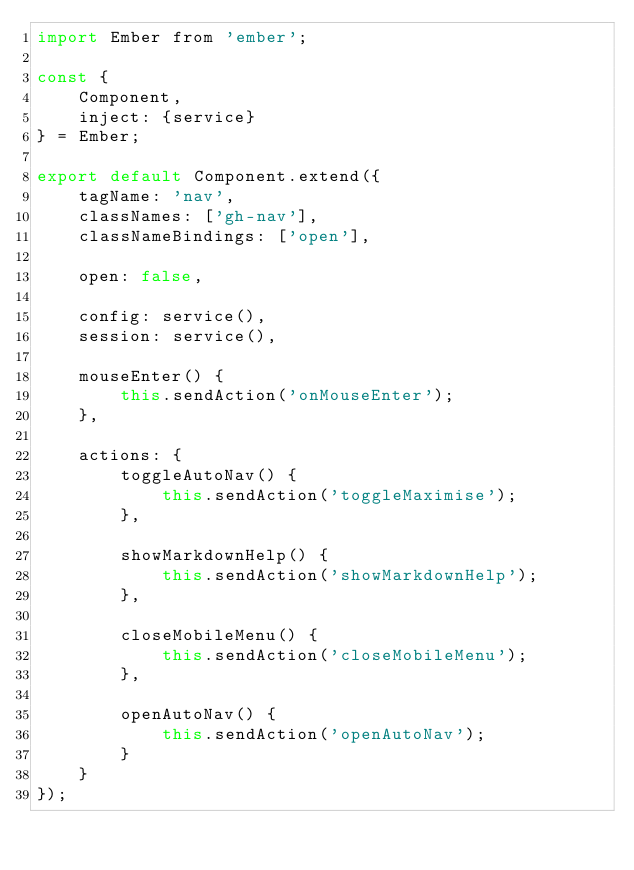<code> <loc_0><loc_0><loc_500><loc_500><_JavaScript_>import Ember from 'ember';

const {
    Component,
    inject: {service}
} = Ember;

export default Component.extend({
    tagName: 'nav',
    classNames: ['gh-nav'],
    classNameBindings: ['open'],

    open: false,

    config: service(),
    session: service(),

    mouseEnter() {
        this.sendAction('onMouseEnter');
    },

    actions: {
        toggleAutoNav() {
            this.sendAction('toggleMaximise');
        },

        showMarkdownHelp() {
            this.sendAction('showMarkdownHelp');
        },

        closeMobileMenu() {
            this.sendAction('closeMobileMenu');
        },

        openAutoNav() {
            this.sendAction('openAutoNav');
        }
    }
});
</code> 